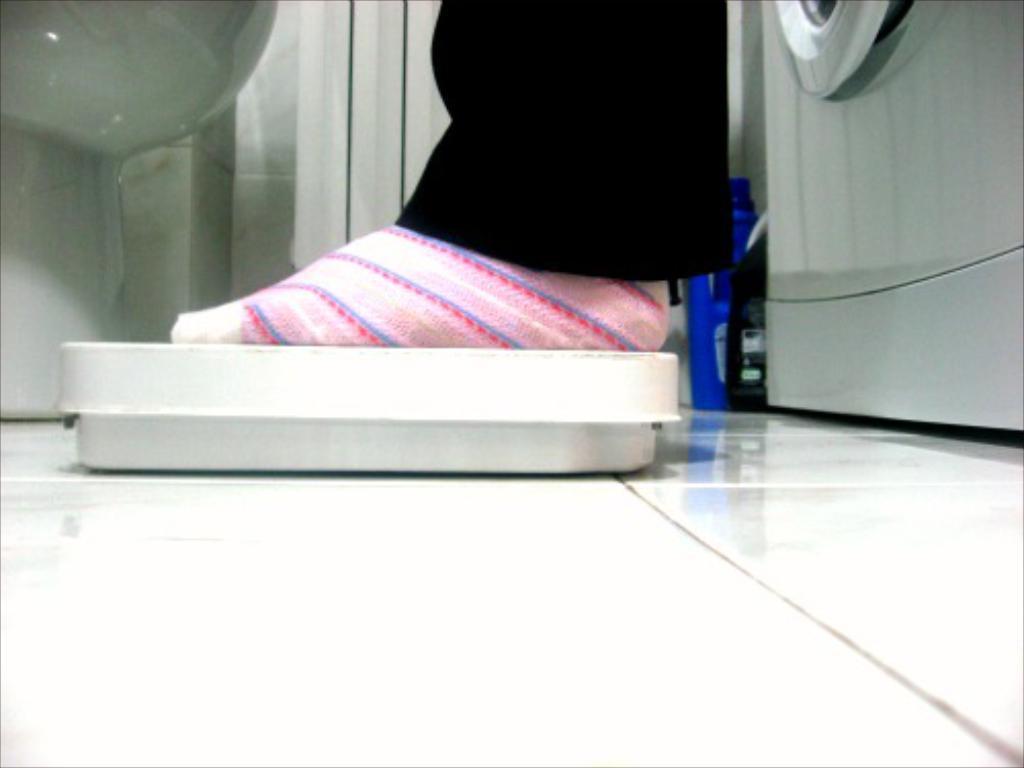Please provide a concise description of this image. In this image there is a person leg on an object which is on the floor. Right side there is a washing machine. Beside there are two bottles. Left side there is an object. Behind there is a wall. 